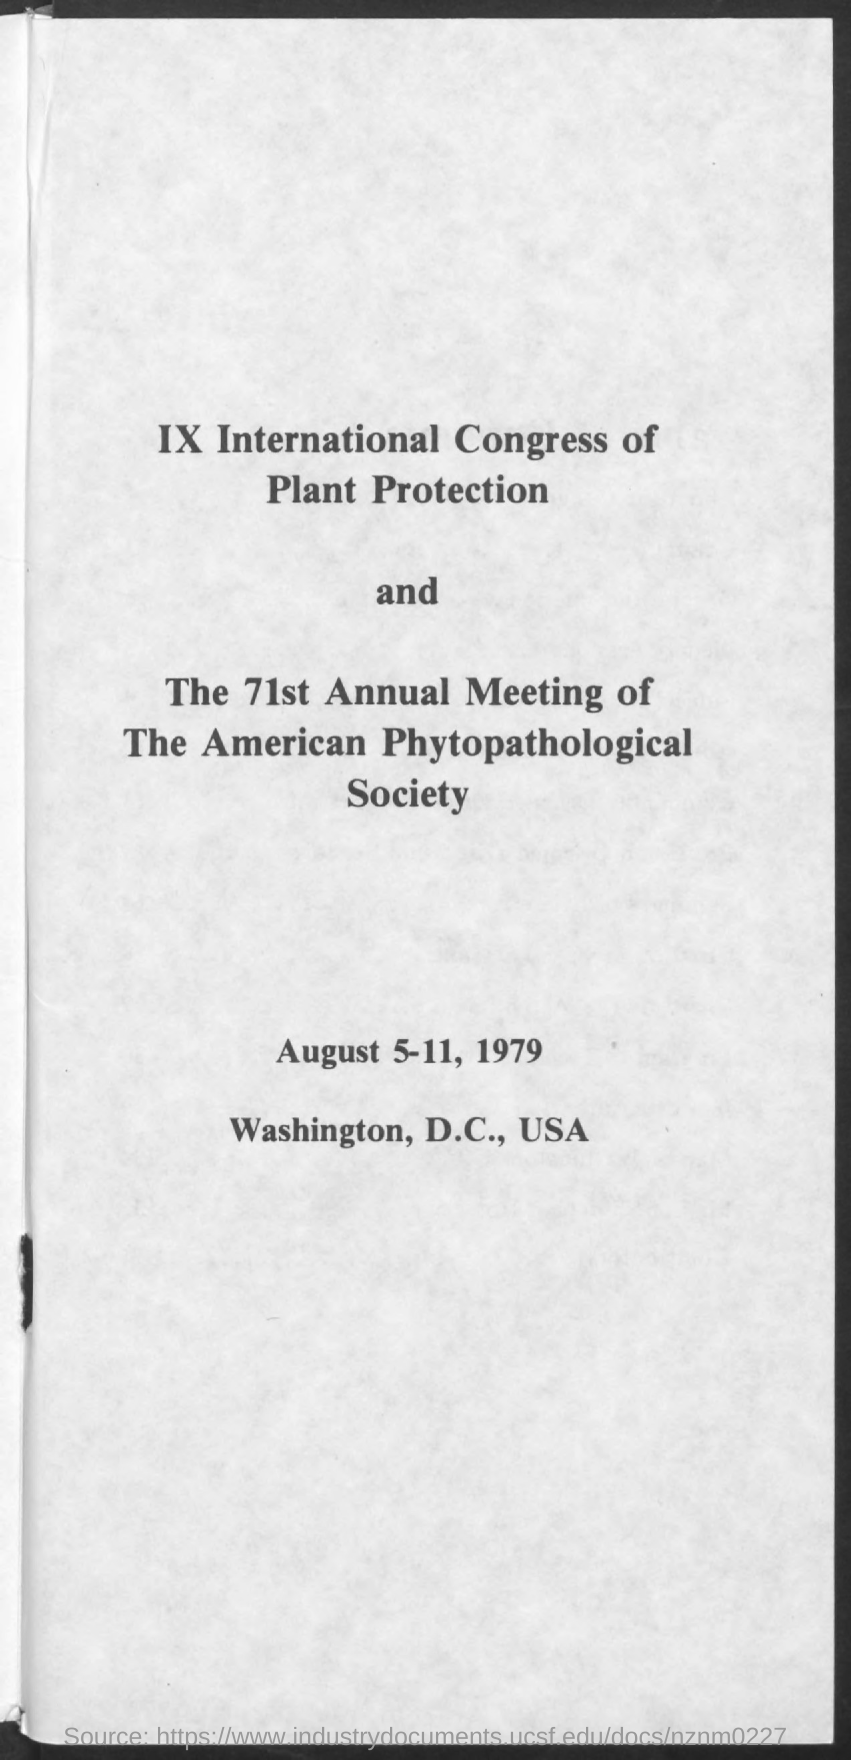Give some essential details in this illustration. The date referred to in the given page is August 5-11, 1979. 